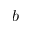<formula> <loc_0><loc_0><loc_500><loc_500>b</formula> 